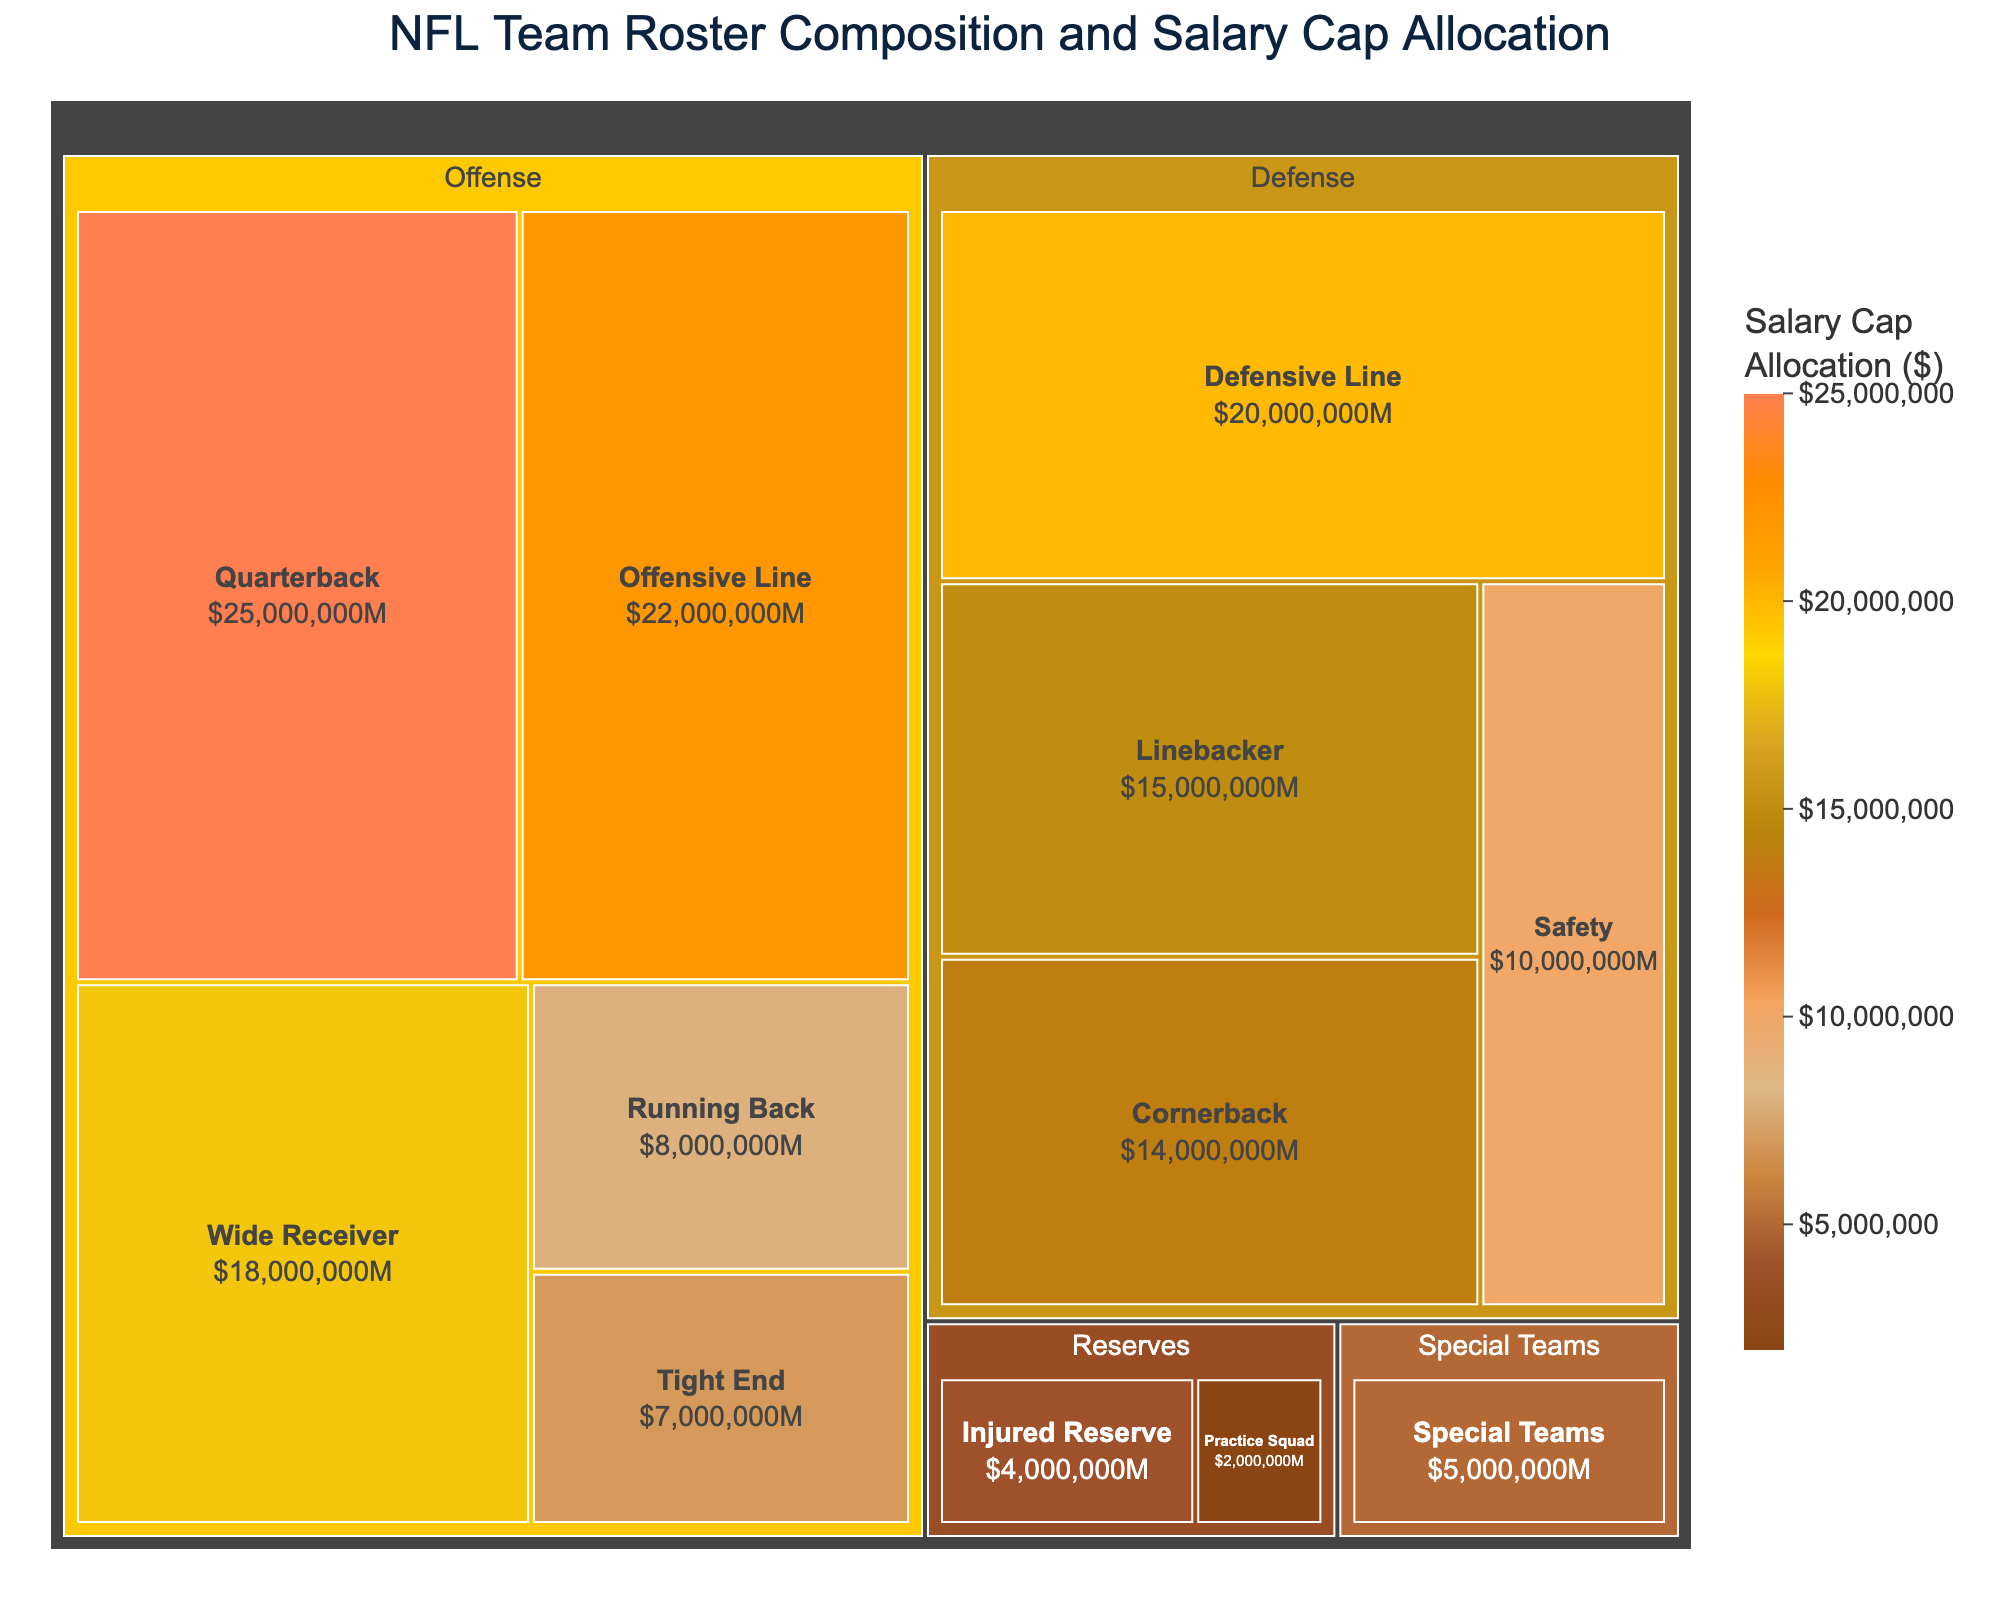What position has the highest salary cap allocation? The largest block in the treemap will indicate the position with the highest salary cap allocation. By observing the size of the blocks, we see that the Quarterback position has the largest allocation.
Answer: Quarterback What is the total salary cap allocation for the Defense category? To find the total, sum the values for Defensive Line ($20,000,000), Linebacker ($15,000,000), Cornerback ($14,000,000), and Safety ($10,000,000). This gives $20,000,000 + $15,000,000 + $14,000,000 + $10,000,000 = $59,000,000.
Answer: $59,000,000 Which category, Offense or Defense, has the greater total salary cap allocation? Sum up the values for each category. For Offense: Quarterback ($25,000,000) + Running Back ($8,000,000) + Wide Receiver ($18,000,000) + Tight End ($7,000,000) + Offensive Line ($22,000,000) = $80,000,000. For Defense: $59,000,000 (calculated previously). Offense has a greater allocation as $80,000,000 > $59,000,000.
Answer: Offense What is the combined salary cap allocation for Special Teams and Reserves? Add the values for Special Teams ($5,000,000), Practice Squad ($2,000,000), and Injured Reserve ($4,000,000). This results in $5,000,000 + $2,000,000 + $4,000,000 = $11,000,000.
Answer: $11,000,000 Which special team role has an allocation of $5,000,000? The block labeled under the Special Teams category with an allocation of $5,000,000 represents the role in question. Here, Special Teams is the only label under this category.
Answer: Special Teams How does the salary cap allocation for Tight End compare with Running Back? The Tight End block is labeled with $7,000,000, and the Running Back block is labeled with $8,000,000. Comparing these two, the Running Back has a higher allocation.
Answer: Running Back > Tight End If we combine the salary cap allocations for Quarterback and Wide Receiver, what is the total? Add the values for Quarterback ($25,000,000) and Wide Receiver ($18,000,000). The total is $25,000,000 + $18,000,000 = $43,000,000.
Answer: $43,000,000 What percentage of the total salary cap allocation is assigned to Offensive Line? First, sum up the total allocation. Adding all values gives us $25,000,000 + $8,000,000 + $18,000,000 + $7,000,000 + $22,000,000 + $20,000,000 + $15,000,000 + $14,000,000 + $10,000,000 + $5,000,000 + $2,000,000 + $4,000,000 = $150,000,000. The percentage for Offensive Line is then ($22,000,000 / $150,000,000) * 100% = 14.67%.
Answer: 14.67% Identify the position with the least salary cap allocation within the Reserves category. The Reserves category includes Practice Squad and Injured Reserve. By comparing the two values, Practice Squad ($2,000,000) has a lesser allocation than Injured Reserve ($4,000,000).
Answer: Practice Squad 